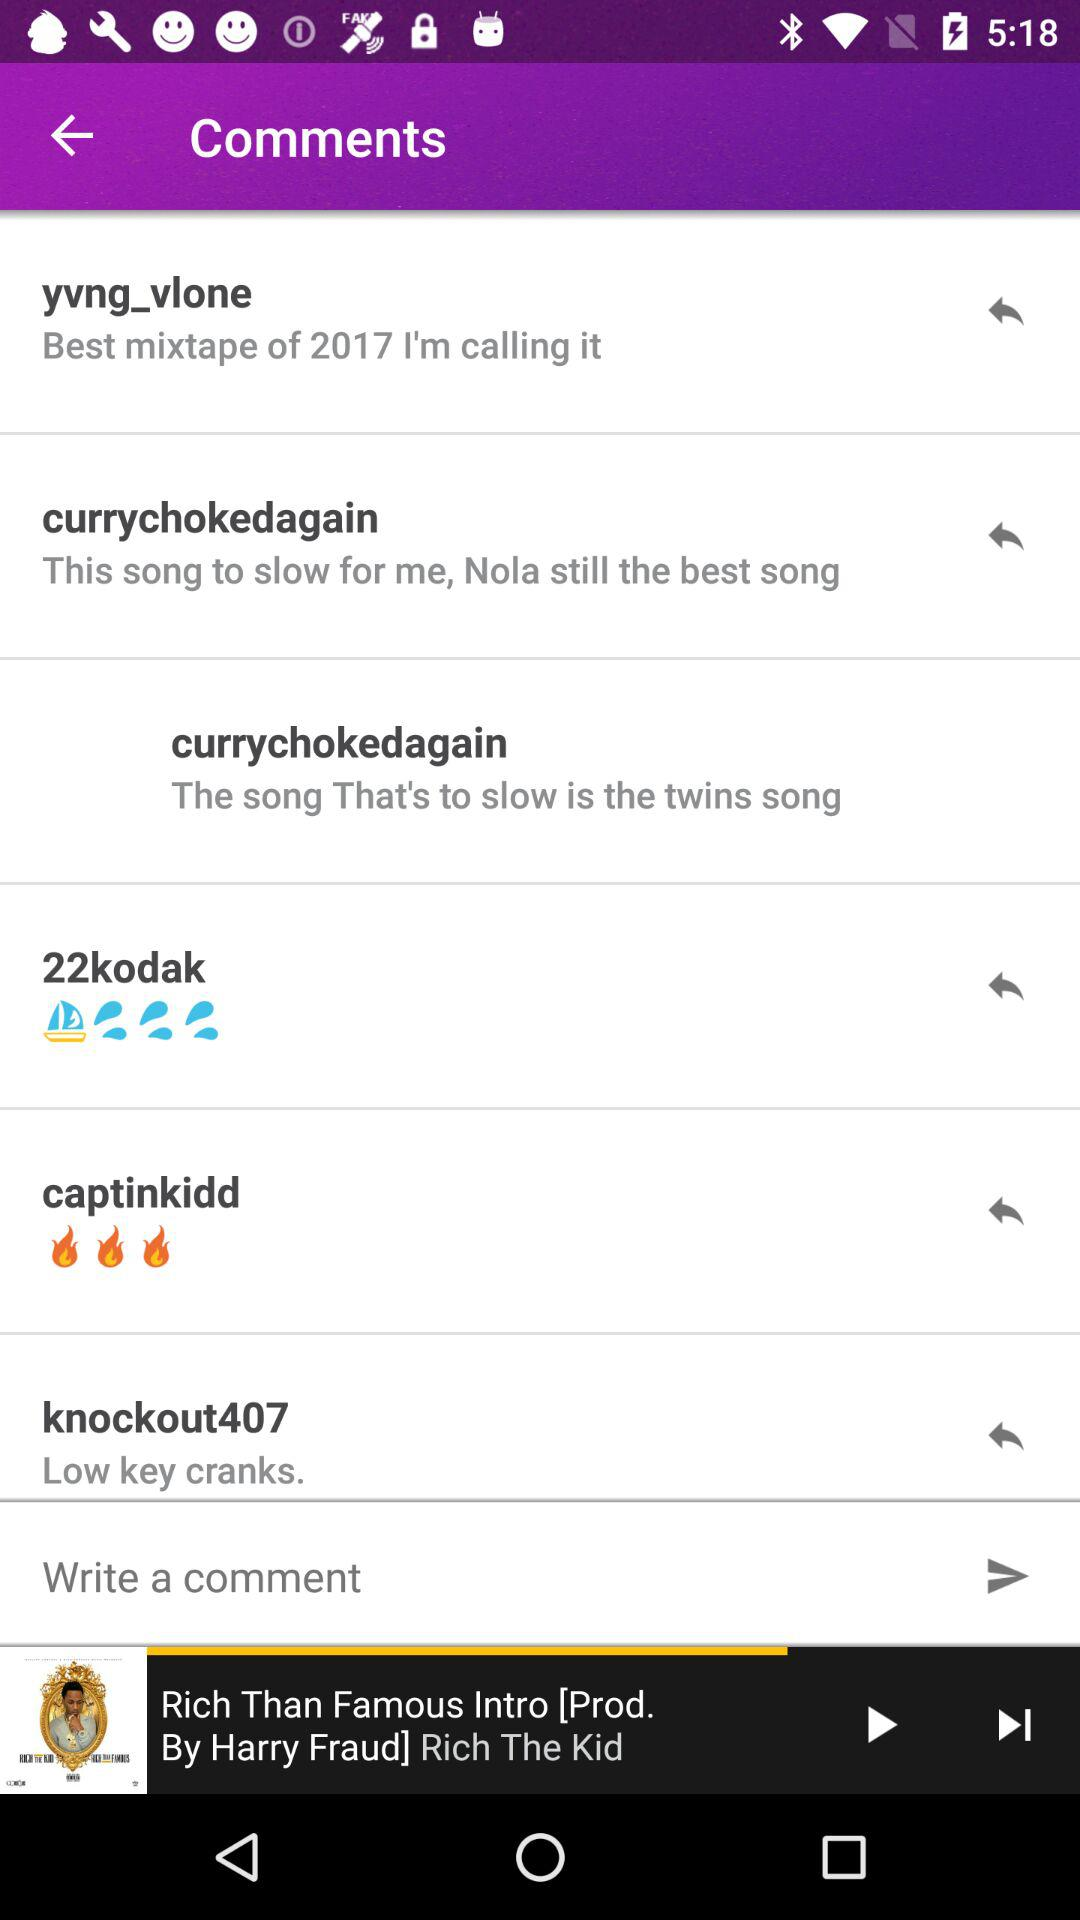What is the name of the song's producer? The name of the song's producer is Harry Fraud. 